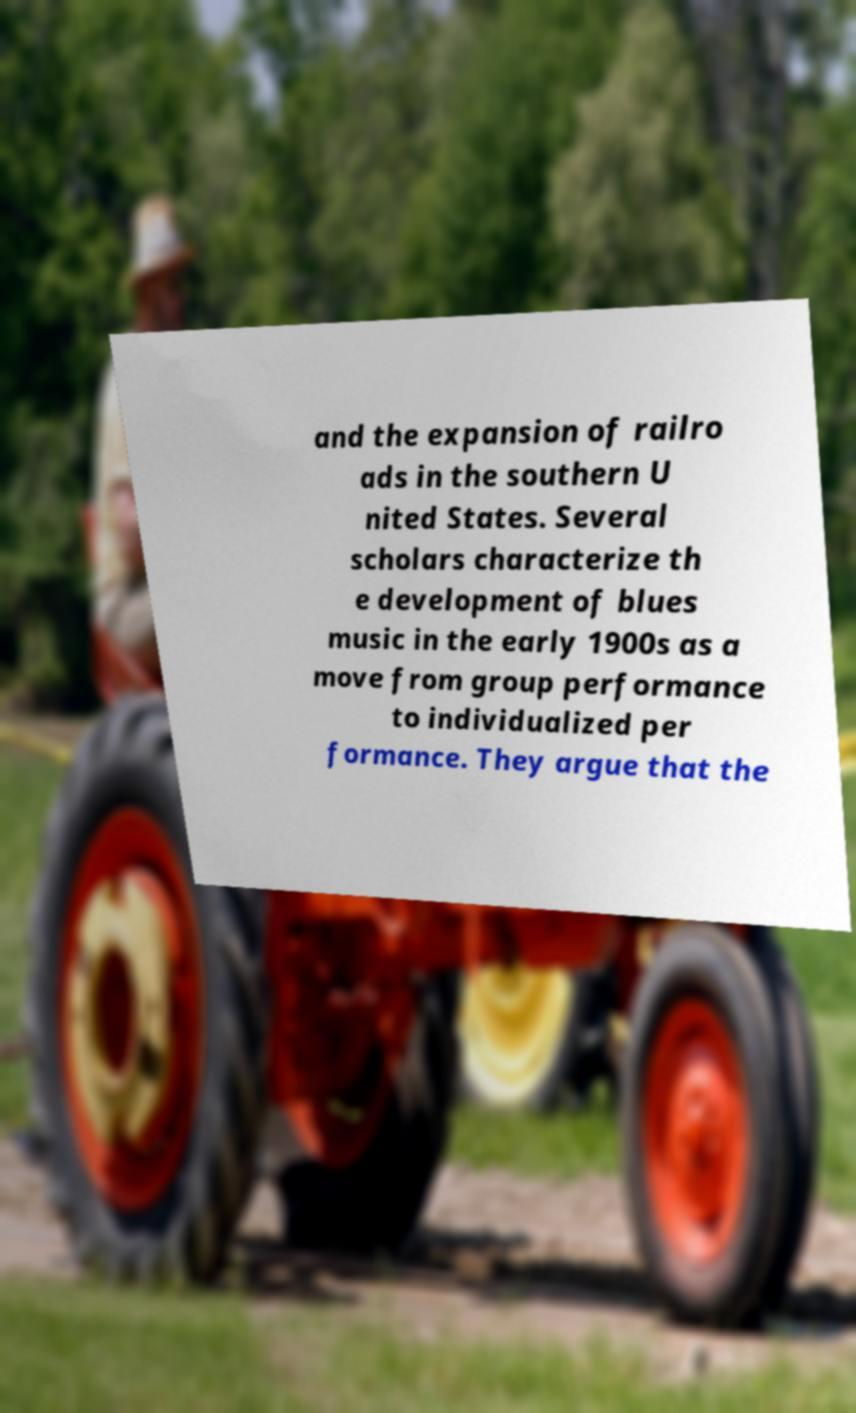Please read and relay the text visible in this image. What does it say? and the expansion of railro ads in the southern U nited States. Several scholars characterize th e development of blues music in the early 1900s as a move from group performance to individualized per formance. They argue that the 